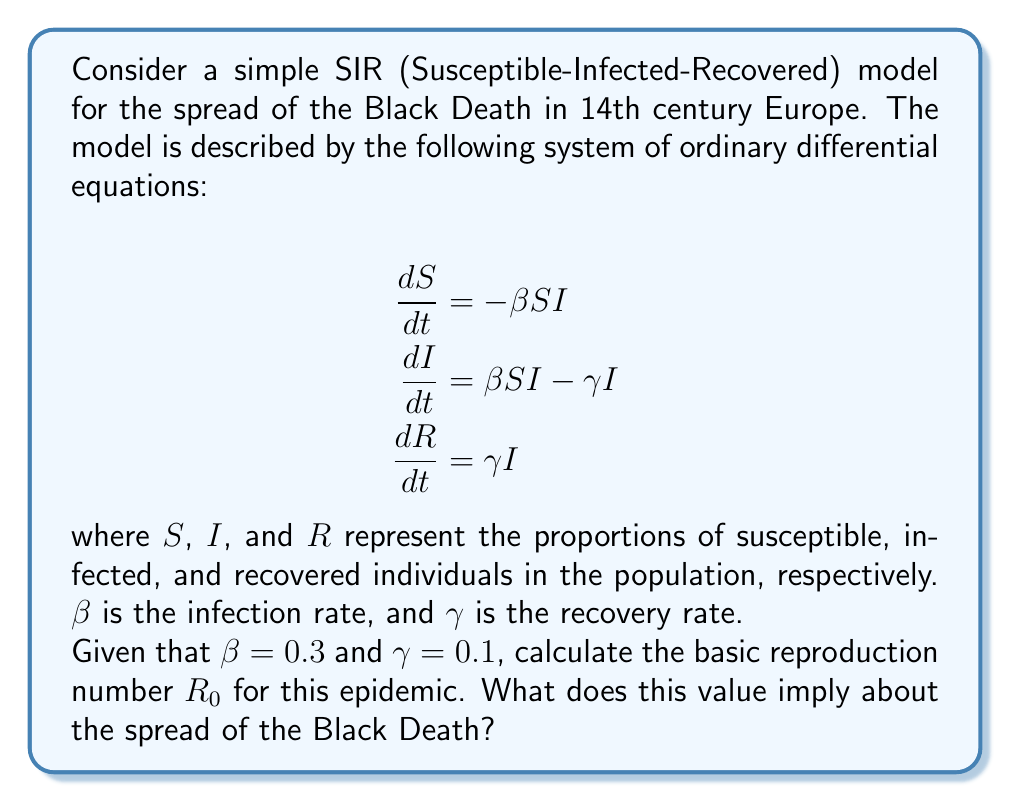Teach me how to tackle this problem. To solve this problem, we need to understand the concept of the basic reproduction number $R_0$ and how it relates to the SIR model parameters.

1. The basic reproduction number $R_0$ is defined as the average number of secondary infections caused by one infected individual in a completely susceptible population.

2. For the SIR model, $R_0$ is given by the formula:

   $$R_0 = \frac{\beta}{\gamma}$$

   where $\beta$ is the infection rate and $\gamma$ is the recovery rate.

3. We are given that $\beta = 0.3$ and $\gamma = 0.1$. Let's substitute these values into the formula:

   $$R_0 = \frac{0.3}{0.1} = 3$$

4. Interpretation of $R_0$:
   - If $R_0 > 1$, the disease will spread exponentially in the population.
   - If $R_0 < 1$, the disease will die out over time.
   - If $R_0 = 1$, the disease will become endemic (constant presence in the population).

5. In this case, $R_0 = 3$, which is greater than 1. This implies that, on average, each infected person will infect 3 others during their infectious period.

6. For the Black Death, this high $R_0$ value suggests that the disease would spread rapidly through the population, leading to a severe epidemic. This aligns with historical accounts of the devastating impact of the Black Death in 14th century Europe.
Answer: The basic reproduction number $R_0$ for the Black Death model is 3. This value implies that the disease would spread rapidly and exponentially through the population, consistent with the historical severity of the Black Death epidemic in 14th century Europe. 